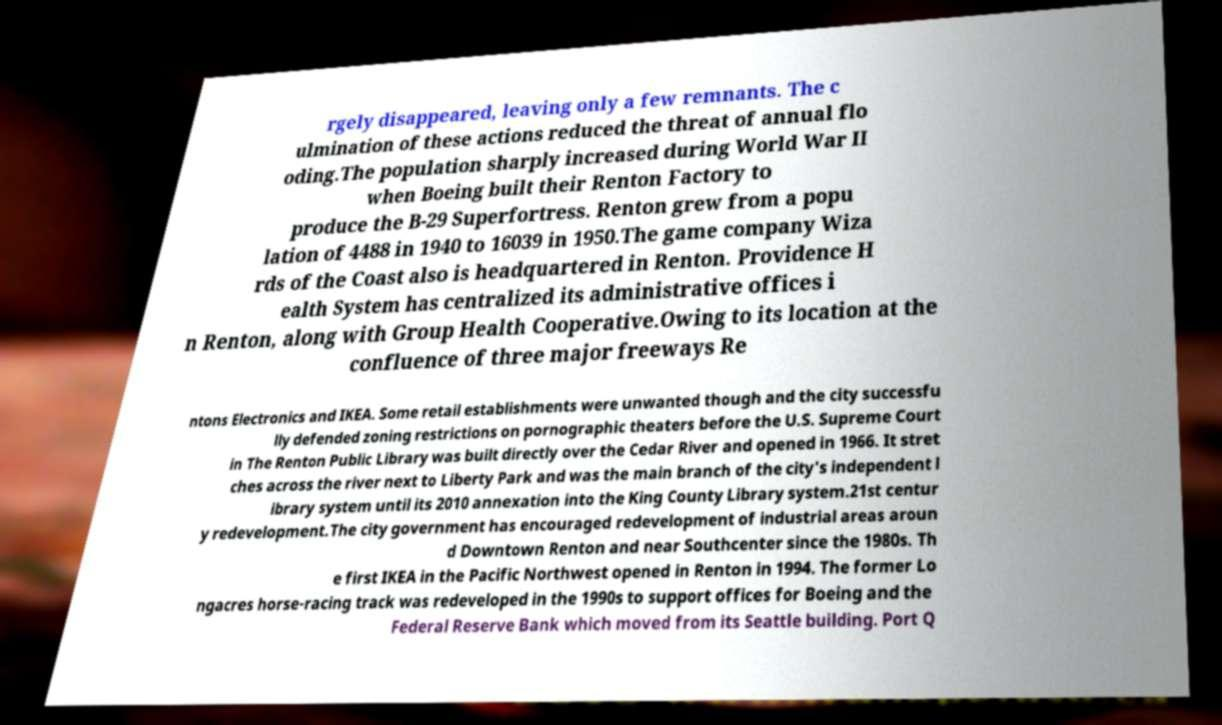Please read and relay the text visible in this image. What does it say? rgely disappeared, leaving only a few remnants. The c ulmination of these actions reduced the threat of annual flo oding.The population sharply increased during World War II when Boeing built their Renton Factory to produce the B-29 Superfortress. Renton grew from a popu lation of 4488 in 1940 to 16039 in 1950.The game company Wiza rds of the Coast also is headquartered in Renton. Providence H ealth System has centralized its administrative offices i n Renton, along with Group Health Cooperative.Owing to its location at the confluence of three major freeways Re ntons Electronics and IKEA. Some retail establishments were unwanted though and the city successfu lly defended zoning restrictions on pornographic theaters before the U.S. Supreme Court in The Renton Public Library was built directly over the Cedar River and opened in 1966. It stret ches across the river next to Liberty Park and was the main branch of the city's independent l ibrary system until its 2010 annexation into the King County Library system.21st centur y redevelopment.The city government has encouraged redevelopment of industrial areas aroun d Downtown Renton and near Southcenter since the 1980s. Th e first IKEA in the Pacific Northwest opened in Renton in 1994. The former Lo ngacres horse-racing track was redeveloped in the 1990s to support offices for Boeing and the Federal Reserve Bank which moved from its Seattle building. Port Q 